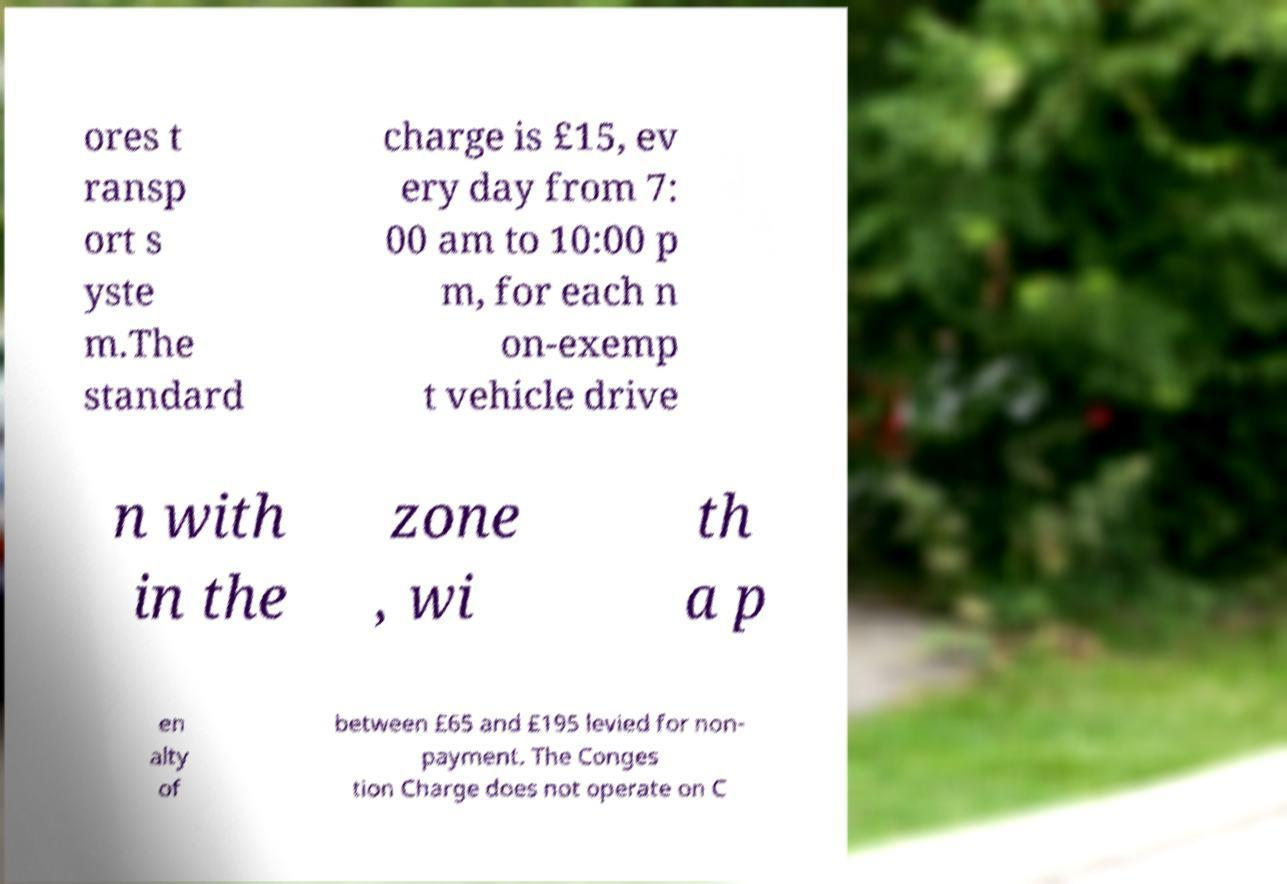Please identify and transcribe the text found in this image. ores t ransp ort s yste m.The standard charge is £15, ev ery day from 7: 00 am to 10:00 p m, for each n on-exemp t vehicle drive n with in the zone , wi th a p en alty of between £65 and £195 levied for non- payment. The Conges tion Charge does not operate on C 